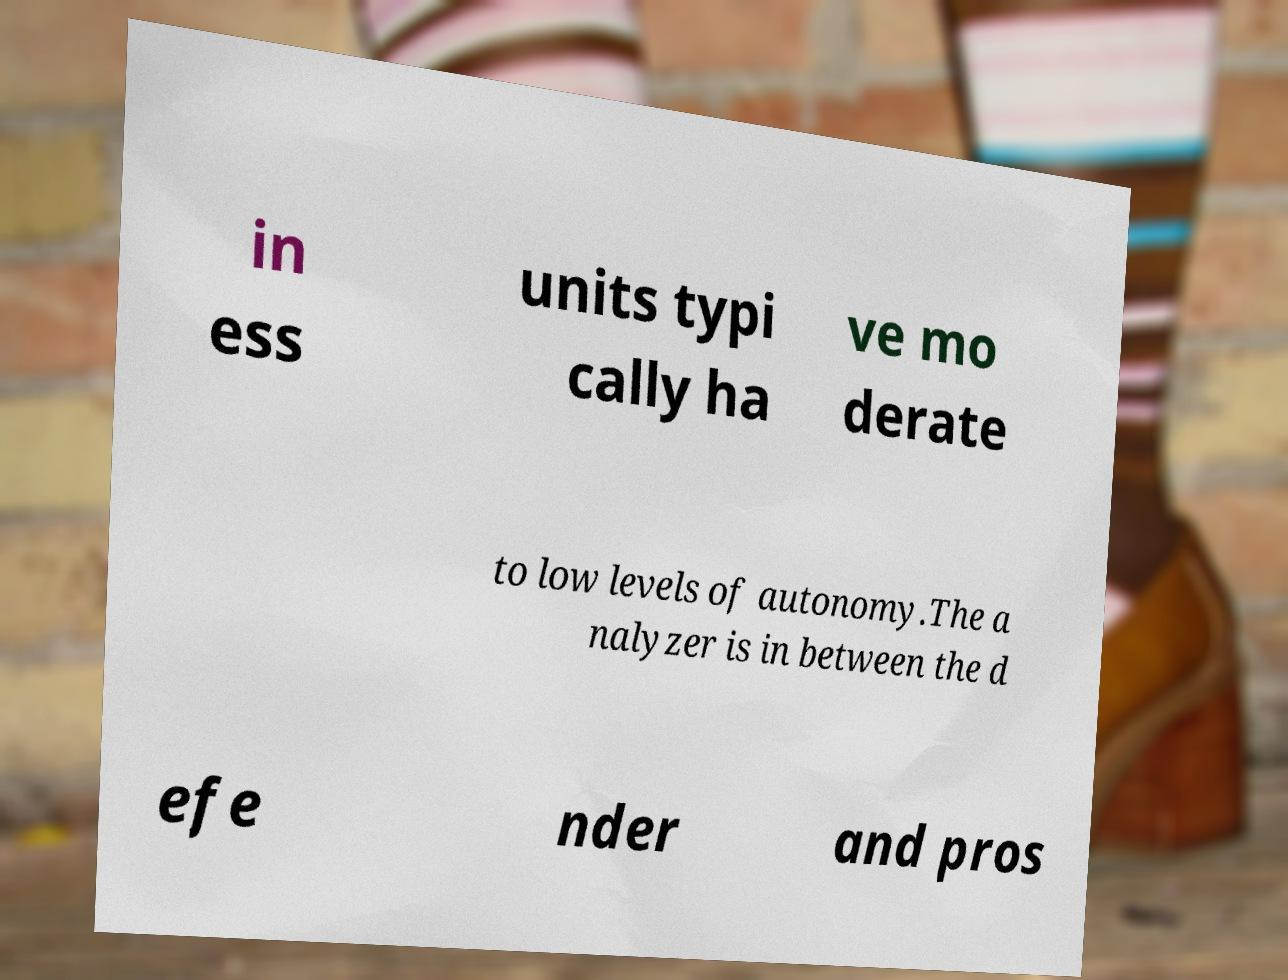Could you assist in decoding the text presented in this image and type it out clearly? in ess units typi cally ha ve mo derate to low levels of autonomy.The a nalyzer is in between the d efe nder and pros 